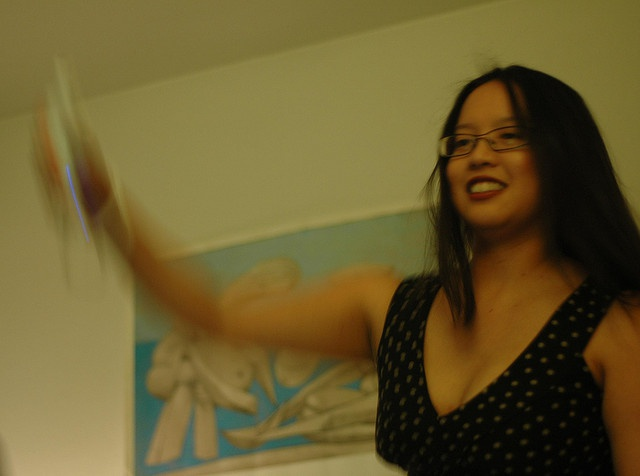Describe the objects in this image and their specific colors. I can see people in olive, black, and maroon tones and remote in olive tones in this image. 